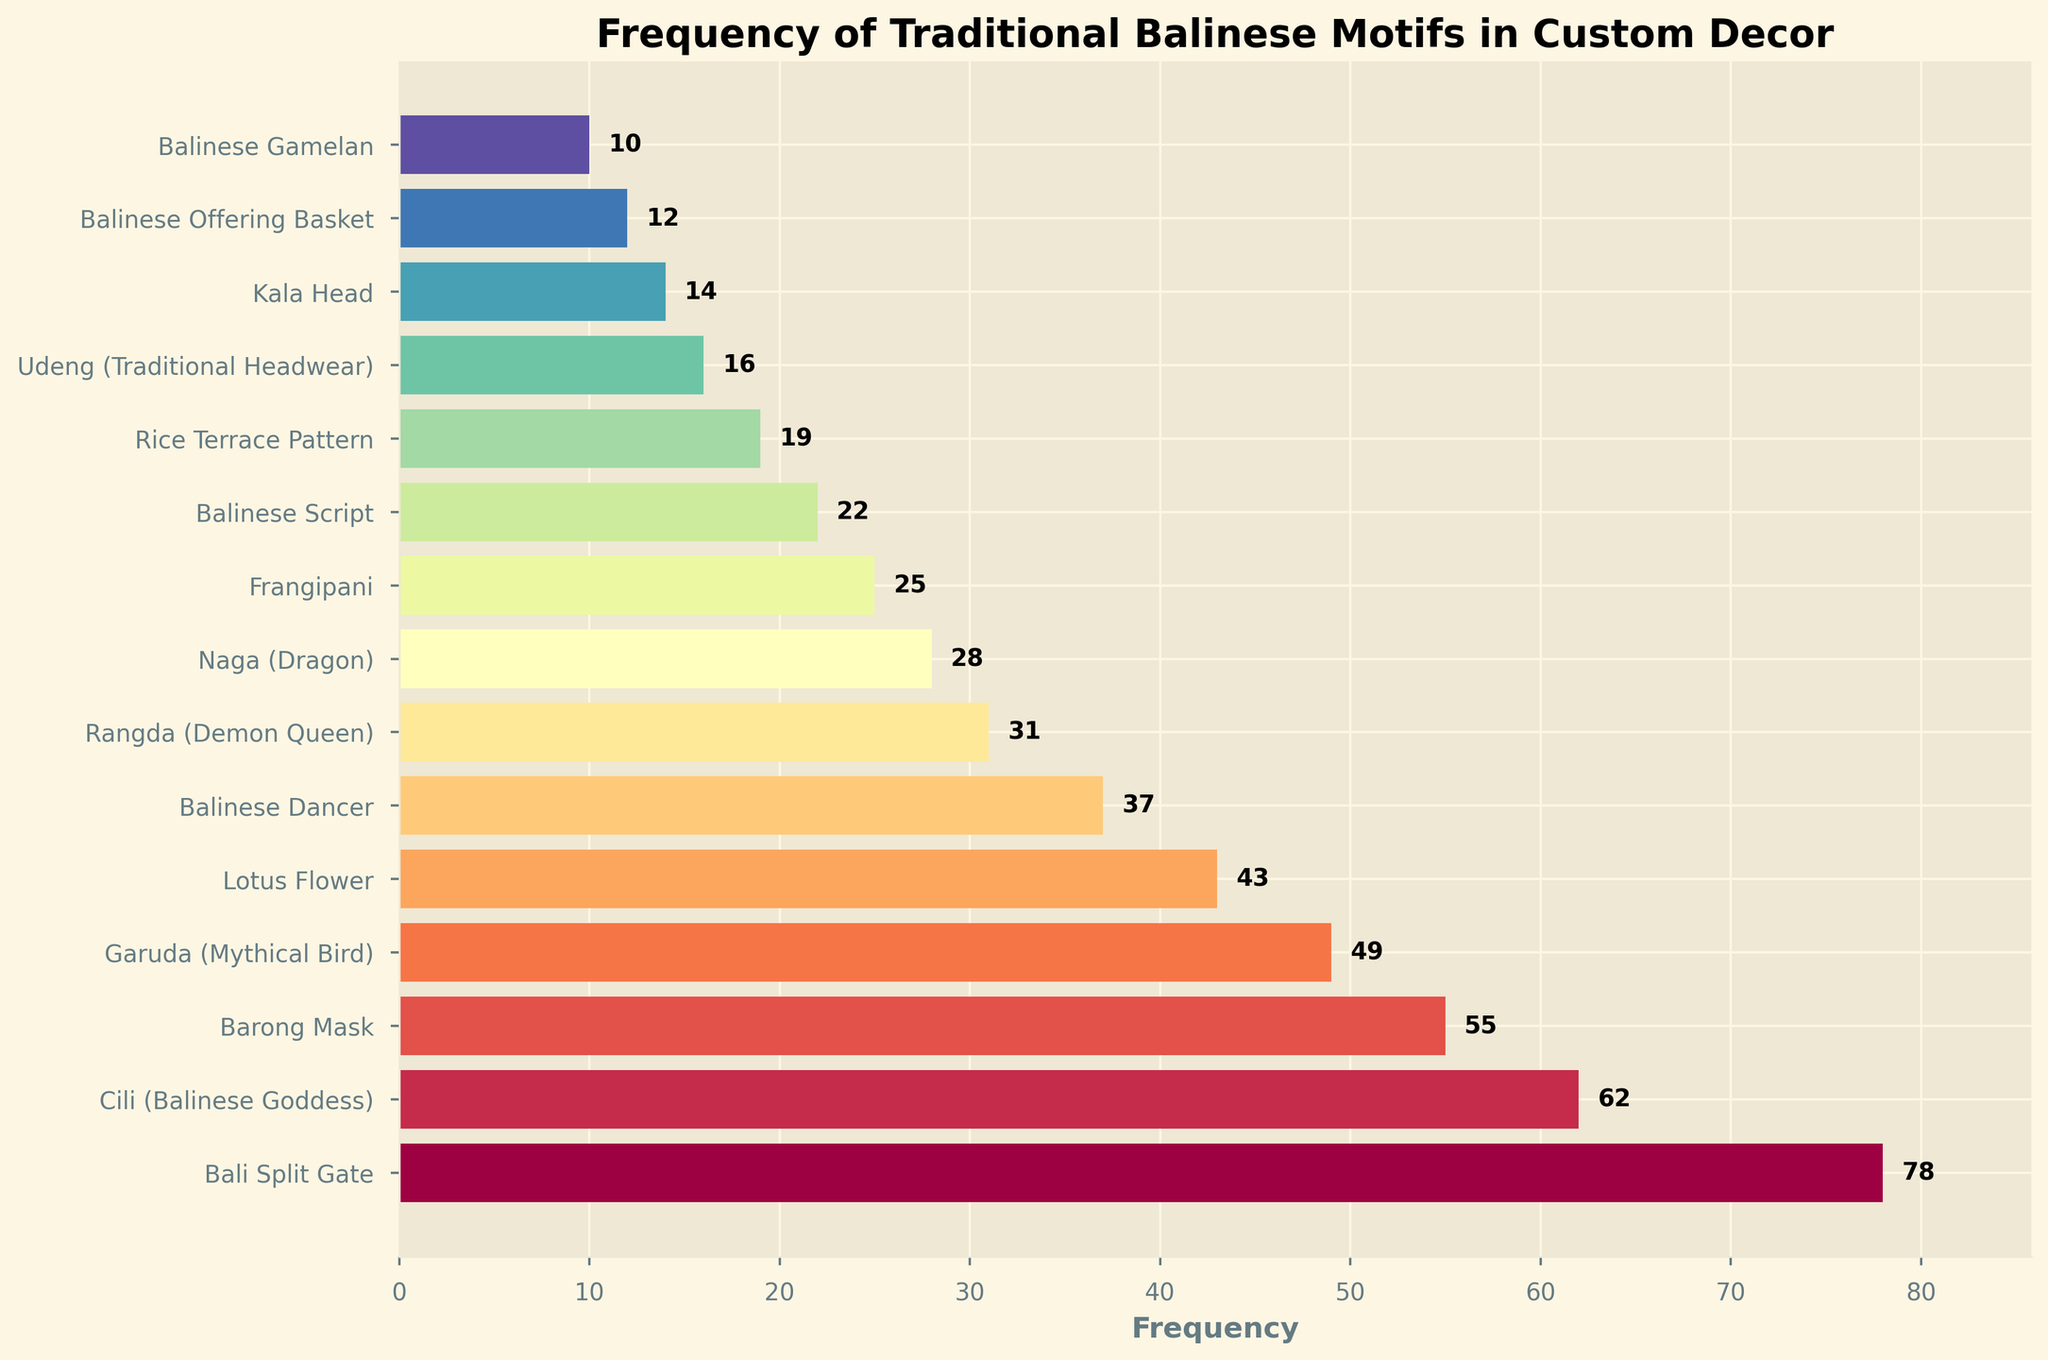What's the most frequently used traditional Balinese motif? Look at the bar that reaches the farthest to the right, which represents the highest frequency. This is the "Bali Split Gate" motif with a frequency of 78.
Answer: Bali Split Gate Which motif is used more frequently: Barong Mask or Lotus Flower? Compare the lengths of the bars for "Barong Mask" and "Lotus Flower." The "Barong Mask" has a longer bar with a frequency of 55, while the "Lotus Flower" has a frequency of 43.
Answer: Barong Mask What is the combined frequency of the top three most frequently used motifs? Identify the top three motifs: "Bali Split Gate" (78), "Cili (Balinese Goddess)" (62), and "Barong Mask" (55). Add their frequencies: 78 + 62 + 55 = 195.
Answer: 195 How many motifs have a frequency above 40? Count the bars that extend to a value greater than 40. These are "Bali Split Gate," "Cili (Balinese Goddess)," "Barong Mask," "Garuda (Mythical Bird)," and "Lotus Flower." There are 5 motifs in total.
Answer: 5 What is the least frequently used motif? The shortest bar represents the motif with the smallest frequency. This is the "Balinese Gamelan" with a frequency of 10.
Answer: Balinese Gamelan Which motifs have a frequency between 20 and 40? Identify the bars that fall within the frequency range of 20 to 40: "Balinese Dancer" (37), "Rangda (Demon Queen)" (31), "Naga (Dragon)" (28), "Frangipani" (25), and "Balinese Script" (22).
Answer: Balinese Dancer, Rangda (Demon Queen), Naga (Dragon), Frangipani, Balinese Script What is the average frequency of all the motifs? Add together all the frequencies: 78 + 62 + 55 + 49 + 43 + 37 + 31 + 28 + 25 + 22 + 19 + 16 + 14 + 12 + 10 = 501. Divide by the number of motifs (15): 501 / 15 = 33.4.
Answer: 33.4 Which two motifs have the closest frequencies? Look for bars with the smallest difference in length. The frequencies of "Frangipani" (25) and "Balinese Script" (22) are close, with a difference of 3.
Answer: Frangipani and Balinese Script How much more frequently is "Cili (Balinese Goddess)" used compared to "Garuda (Mythical Bird)"? Subtract the frequency of "Garuda (Mythical Bird)" (49) from the frequency of "Cili (Balinese Goddess)" (62): 62 - 49 = 13.
Answer: 13 What is the difference in frequency between the most frequently used motif and the least frequently used motif? Subtract the frequency of "Balinese Gamelan" (10) from "Bali Split Gate" (78): 78 - 10 = 68.
Answer: 68 